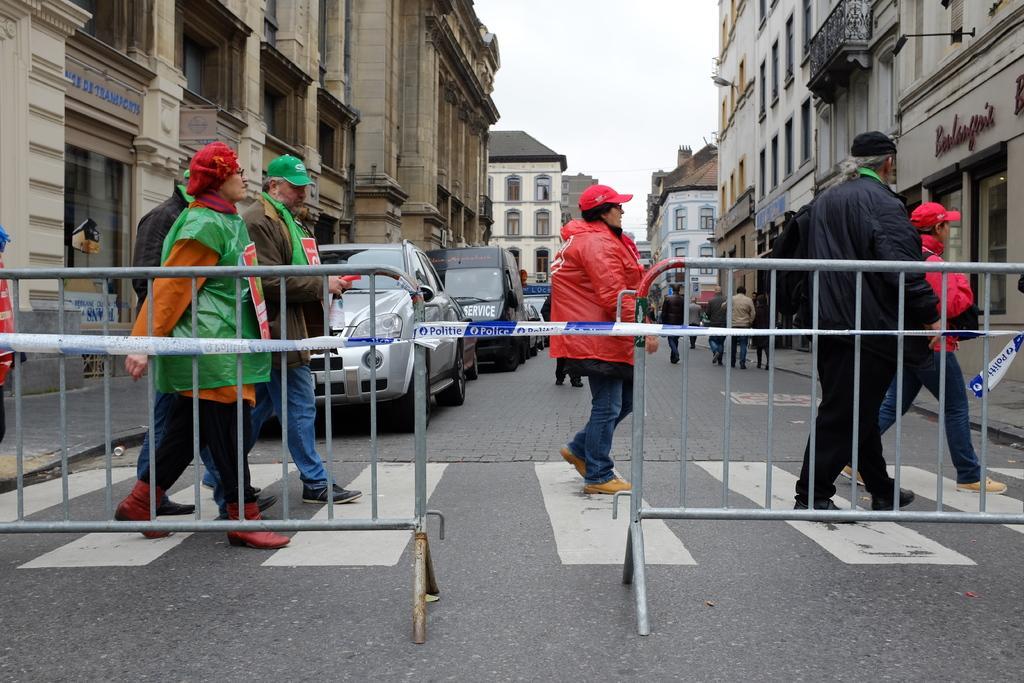In one or two sentences, can you explain what this image depicts? In this picture I can observe some people crossing the road. Beside them I can observe railings. On the left side I can observe cars parked on the road. On either sides of the road I can observe buildings. In the background I can observe sky. 